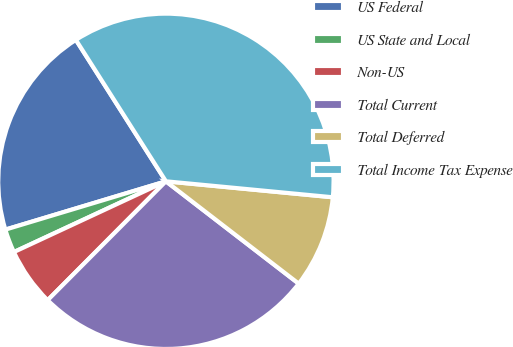Convert chart to OTSL. <chart><loc_0><loc_0><loc_500><loc_500><pie_chart><fcel>US Federal<fcel>US State and Local<fcel>Non-US<fcel>Total Current<fcel>Total Deferred<fcel>Total Income Tax Expense<nl><fcel>20.63%<fcel>2.28%<fcel>5.61%<fcel>27.01%<fcel>8.93%<fcel>35.54%<nl></chart> 